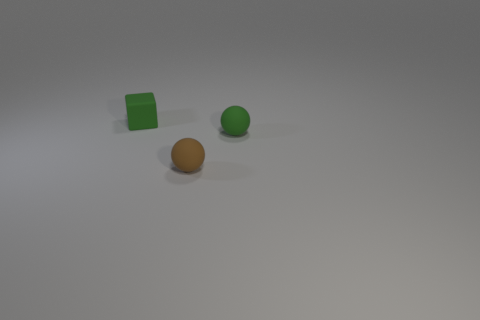Are there any shadows visible that provide insights about the lighting? Yes, there are subtle shadows extending to the left of each object, indicating a light source positioned to their right, likely off-frame. 